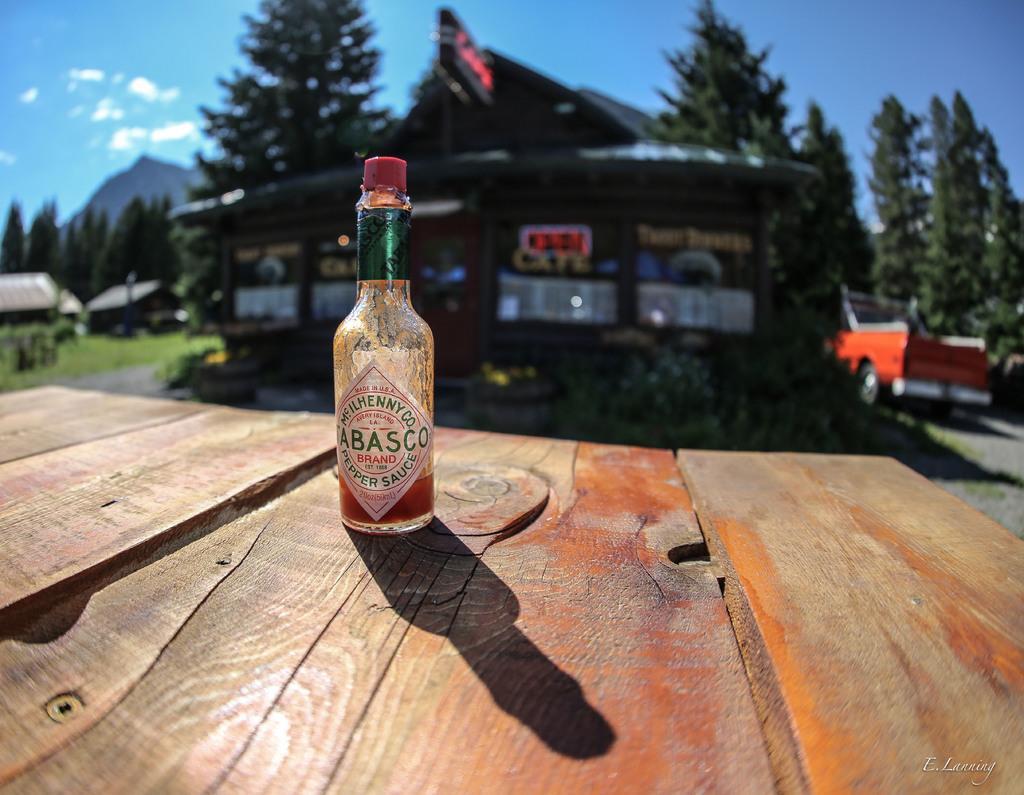Please provide a concise description of this image. This image is clicked outside. In the front, there is a wooden table on which a sauce bottle is kept. The cap is in red color. In the background, there are trees, mountains, and clouds, along with a house and car. 